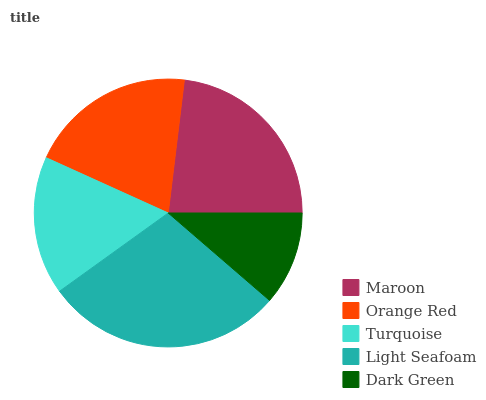Is Dark Green the minimum?
Answer yes or no. Yes. Is Light Seafoam the maximum?
Answer yes or no. Yes. Is Orange Red the minimum?
Answer yes or no. No. Is Orange Red the maximum?
Answer yes or no. No. Is Maroon greater than Orange Red?
Answer yes or no. Yes. Is Orange Red less than Maroon?
Answer yes or no. Yes. Is Orange Red greater than Maroon?
Answer yes or no. No. Is Maroon less than Orange Red?
Answer yes or no. No. Is Orange Red the high median?
Answer yes or no. Yes. Is Orange Red the low median?
Answer yes or no. Yes. Is Light Seafoam the high median?
Answer yes or no. No. Is Light Seafoam the low median?
Answer yes or no. No. 